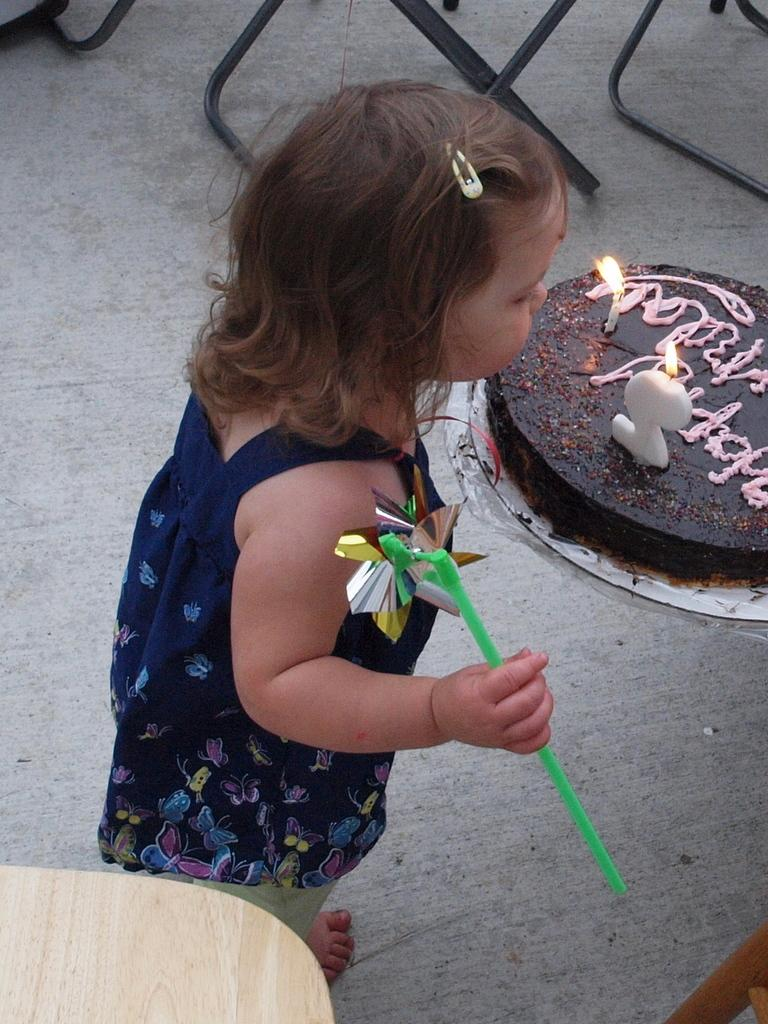Who is the main subject in the image? There is a girl in the image. What is the girl standing next to? There is a cake in the image. What is special about the cake? The cake has candles. What is the girl holding in her hand? The girl is holding an object. What type of operation is the girl performing on the cake in the image? There is no operation being performed on the cake in the image. The girl is simply standing next to it. 